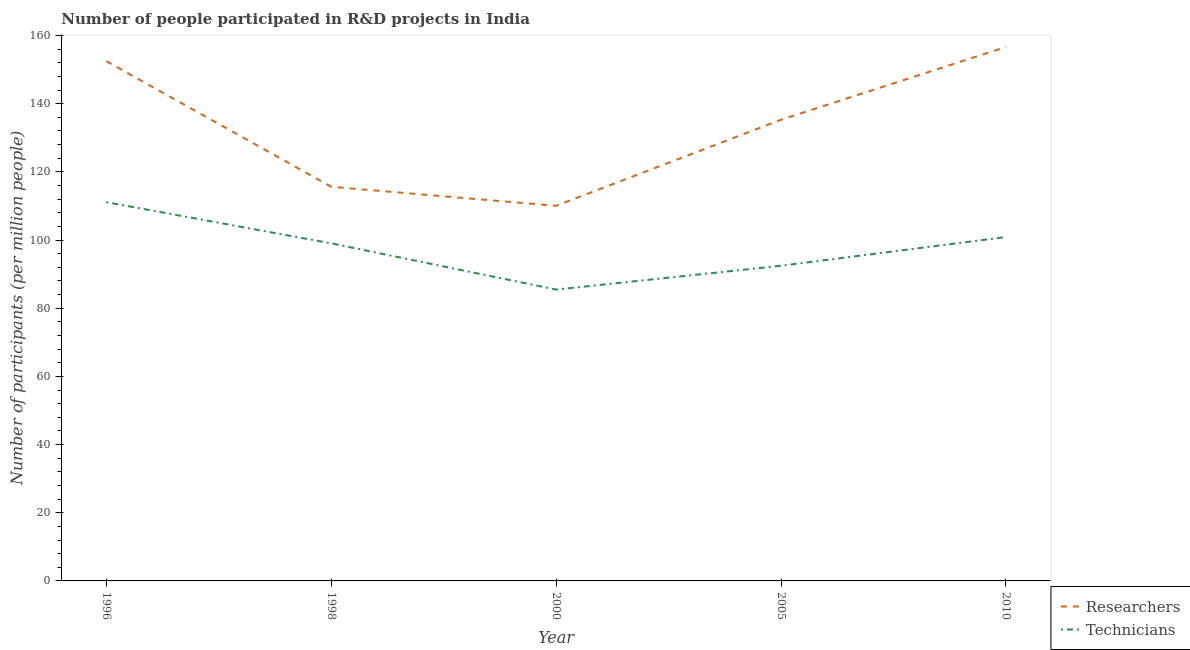Does the line corresponding to number of researchers intersect with the line corresponding to number of technicians?
Provide a succinct answer. No. Is the number of lines equal to the number of legend labels?
Provide a succinct answer. Yes. What is the number of technicians in 2010?
Provide a short and direct response. 100.89. Across all years, what is the maximum number of technicians?
Provide a succinct answer. 111.12. Across all years, what is the minimum number of researchers?
Give a very brief answer. 110.05. In which year was the number of technicians minimum?
Keep it short and to the point. 2000. What is the total number of researchers in the graph?
Provide a short and direct response. 670.1. What is the difference between the number of researchers in 2000 and that in 2005?
Offer a very short reply. -25.25. What is the difference between the number of technicians in 2010 and the number of researchers in 1996?
Your answer should be very brief. -51.6. What is the average number of technicians per year?
Provide a succinct answer. 97.79. In the year 1996, what is the difference between the number of researchers and number of technicians?
Ensure brevity in your answer.  41.37. In how many years, is the number of researchers greater than 80?
Offer a terse response. 5. What is the ratio of the number of technicians in 1998 to that in 2005?
Offer a very short reply. 1.07. What is the difference between the highest and the second highest number of technicians?
Give a very brief answer. 10.23. What is the difference between the highest and the lowest number of technicians?
Your answer should be very brief. 25.64. Does the number of researchers monotonically increase over the years?
Your answer should be compact. No. Is the number of technicians strictly less than the number of researchers over the years?
Your answer should be very brief. Yes. How many lines are there?
Your answer should be compact. 2. How many years are there in the graph?
Keep it short and to the point. 5. Are the values on the major ticks of Y-axis written in scientific E-notation?
Provide a short and direct response. No. How are the legend labels stacked?
Offer a very short reply. Vertical. What is the title of the graph?
Keep it short and to the point. Number of people participated in R&D projects in India. Does "International Visitors" appear as one of the legend labels in the graph?
Your answer should be very brief. No. What is the label or title of the Y-axis?
Offer a very short reply. Number of participants (per million people). What is the Number of participants (per million people) in Researchers in 1996?
Give a very brief answer. 152.48. What is the Number of participants (per million people) in Technicians in 1996?
Offer a very short reply. 111.12. What is the Number of participants (per million people) of Researchers in 1998?
Your answer should be very brief. 115.63. What is the Number of participants (per million people) in Technicians in 1998?
Your answer should be very brief. 99.03. What is the Number of participants (per million people) of Researchers in 2000?
Your answer should be compact. 110.05. What is the Number of participants (per million people) of Technicians in 2000?
Make the answer very short. 85.47. What is the Number of participants (per million people) in Researchers in 2005?
Keep it short and to the point. 135.3. What is the Number of participants (per million people) in Technicians in 2005?
Provide a succinct answer. 92.46. What is the Number of participants (per million people) of Researchers in 2010?
Offer a terse response. 156.64. What is the Number of participants (per million people) in Technicians in 2010?
Your answer should be very brief. 100.89. Across all years, what is the maximum Number of participants (per million people) of Researchers?
Your answer should be very brief. 156.64. Across all years, what is the maximum Number of participants (per million people) in Technicians?
Your answer should be compact. 111.12. Across all years, what is the minimum Number of participants (per million people) in Researchers?
Your answer should be compact. 110.05. Across all years, what is the minimum Number of participants (per million people) in Technicians?
Give a very brief answer. 85.47. What is the total Number of participants (per million people) in Researchers in the graph?
Provide a short and direct response. 670.1. What is the total Number of participants (per million people) of Technicians in the graph?
Provide a succinct answer. 488.97. What is the difference between the Number of participants (per million people) of Researchers in 1996 and that in 1998?
Ensure brevity in your answer.  36.85. What is the difference between the Number of participants (per million people) of Technicians in 1996 and that in 1998?
Your response must be concise. 12.09. What is the difference between the Number of participants (per million people) of Researchers in 1996 and that in 2000?
Keep it short and to the point. 42.43. What is the difference between the Number of participants (per million people) of Technicians in 1996 and that in 2000?
Your response must be concise. 25.64. What is the difference between the Number of participants (per million people) of Researchers in 1996 and that in 2005?
Offer a terse response. 17.18. What is the difference between the Number of participants (per million people) of Technicians in 1996 and that in 2005?
Your answer should be very brief. 18.66. What is the difference between the Number of participants (per million people) in Researchers in 1996 and that in 2010?
Keep it short and to the point. -4.15. What is the difference between the Number of participants (per million people) of Technicians in 1996 and that in 2010?
Your response must be concise. 10.23. What is the difference between the Number of participants (per million people) in Researchers in 1998 and that in 2000?
Your response must be concise. 5.58. What is the difference between the Number of participants (per million people) in Technicians in 1998 and that in 2000?
Offer a terse response. 13.56. What is the difference between the Number of participants (per million people) in Researchers in 1998 and that in 2005?
Provide a succinct answer. -19.67. What is the difference between the Number of participants (per million people) of Technicians in 1998 and that in 2005?
Make the answer very short. 6.57. What is the difference between the Number of participants (per million people) in Researchers in 1998 and that in 2010?
Give a very brief answer. -41.01. What is the difference between the Number of participants (per million people) in Technicians in 1998 and that in 2010?
Provide a short and direct response. -1.85. What is the difference between the Number of participants (per million people) of Researchers in 2000 and that in 2005?
Provide a succinct answer. -25.25. What is the difference between the Number of participants (per million people) of Technicians in 2000 and that in 2005?
Offer a terse response. -6.99. What is the difference between the Number of participants (per million people) of Researchers in 2000 and that in 2010?
Give a very brief answer. -46.59. What is the difference between the Number of participants (per million people) of Technicians in 2000 and that in 2010?
Ensure brevity in your answer.  -15.41. What is the difference between the Number of participants (per million people) in Researchers in 2005 and that in 2010?
Give a very brief answer. -21.34. What is the difference between the Number of participants (per million people) in Technicians in 2005 and that in 2010?
Keep it short and to the point. -8.42. What is the difference between the Number of participants (per million people) of Researchers in 1996 and the Number of participants (per million people) of Technicians in 1998?
Offer a very short reply. 53.45. What is the difference between the Number of participants (per million people) in Researchers in 1996 and the Number of participants (per million people) in Technicians in 2000?
Provide a short and direct response. 67.01. What is the difference between the Number of participants (per million people) of Researchers in 1996 and the Number of participants (per million people) of Technicians in 2005?
Offer a terse response. 60.02. What is the difference between the Number of participants (per million people) of Researchers in 1996 and the Number of participants (per million people) of Technicians in 2010?
Give a very brief answer. 51.6. What is the difference between the Number of participants (per million people) in Researchers in 1998 and the Number of participants (per million people) in Technicians in 2000?
Your response must be concise. 30.16. What is the difference between the Number of participants (per million people) in Researchers in 1998 and the Number of participants (per million people) in Technicians in 2005?
Your answer should be very brief. 23.17. What is the difference between the Number of participants (per million people) of Researchers in 1998 and the Number of participants (per million people) of Technicians in 2010?
Keep it short and to the point. 14.75. What is the difference between the Number of participants (per million people) in Researchers in 2000 and the Number of participants (per million people) in Technicians in 2005?
Ensure brevity in your answer.  17.59. What is the difference between the Number of participants (per million people) in Researchers in 2000 and the Number of participants (per million people) in Technicians in 2010?
Offer a terse response. 9.17. What is the difference between the Number of participants (per million people) of Researchers in 2005 and the Number of participants (per million people) of Technicians in 2010?
Your answer should be very brief. 34.41. What is the average Number of participants (per million people) of Researchers per year?
Ensure brevity in your answer.  134.02. What is the average Number of participants (per million people) of Technicians per year?
Your answer should be very brief. 97.79. In the year 1996, what is the difference between the Number of participants (per million people) of Researchers and Number of participants (per million people) of Technicians?
Keep it short and to the point. 41.37. In the year 1998, what is the difference between the Number of participants (per million people) of Researchers and Number of participants (per million people) of Technicians?
Your response must be concise. 16.6. In the year 2000, what is the difference between the Number of participants (per million people) of Researchers and Number of participants (per million people) of Technicians?
Offer a terse response. 24.58. In the year 2005, what is the difference between the Number of participants (per million people) in Researchers and Number of participants (per million people) in Technicians?
Provide a succinct answer. 42.84. In the year 2010, what is the difference between the Number of participants (per million people) in Researchers and Number of participants (per million people) in Technicians?
Offer a terse response. 55.75. What is the ratio of the Number of participants (per million people) in Researchers in 1996 to that in 1998?
Your answer should be compact. 1.32. What is the ratio of the Number of participants (per million people) of Technicians in 1996 to that in 1998?
Offer a terse response. 1.12. What is the ratio of the Number of participants (per million people) of Researchers in 1996 to that in 2000?
Your response must be concise. 1.39. What is the ratio of the Number of participants (per million people) of Researchers in 1996 to that in 2005?
Your answer should be compact. 1.13. What is the ratio of the Number of participants (per million people) in Technicians in 1996 to that in 2005?
Give a very brief answer. 1.2. What is the ratio of the Number of participants (per million people) of Researchers in 1996 to that in 2010?
Offer a terse response. 0.97. What is the ratio of the Number of participants (per million people) of Technicians in 1996 to that in 2010?
Make the answer very short. 1.1. What is the ratio of the Number of participants (per million people) in Researchers in 1998 to that in 2000?
Your answer should be compact. 1.05. What is the ratio of the Number of participants (per million people) in Technicians in 1998 to that in 2000?
Make the answer very short. 1.16. What is the ratio of the Number of participants (per million people) of Researchers in 1998 to that in 2005?
Ensure brevity in your answer.  0.85. What is the ratio of the Number of participants (per million people) of Technicians in 1998 to that in 2005?
Keep it short and to the point. 1.07. What is the ratio of the Number of participants (per million people) in Researchers in 1998 to that in 2010?
Keep it short and to the point. 0.74. What is the ratio of the Number of participants (per million people) in Technicians in 1998 to that in 2010?
Your answer should be compact. 0.98. What is the ratio of the Number of participants (per million people) in Researchers in 2000 to that in 2005?
Provide a short and direct response. 0.81. What is the ratio of the Number of participants (per million people) of Technicians in 2000 to that in 2005?
Offer a terse response. 0.92. What is the ratio of the Number of participants (per million people) of Researchers in 2000 to that in 2010?
Your response must be concise. 0.7. What is the ratio of the Number of participants (per million people) of Technicians in 2000 to that in 2010?
Offer a terse response. 0.85. What is the ratio of the Number of participants (per million people) of Researchers in 2005 to that in 2010?
Offer a terse response. 0.86. What is the ratio of the Number of participants (per million people) of Technicians in 2005 to that in 2010?
Offer a very short reply. 0.92. What is the difference between the highest and the second highest Number of participants (per million people) in Researchers?
Keep it short and to the point. 4.15. What is the difference between the highest and the second highest Number of participants (per million people) of Technicians?
Provide a succinct answer. 10.23. What is the difference between the highest and the lowest Number of participants (per million people) in Researchers?
Offer a very short reply. 46.59. What is the difference between the highest and the lowest Number of participants (per million people) of Technicians?
Make the answer very short. 25.64. 